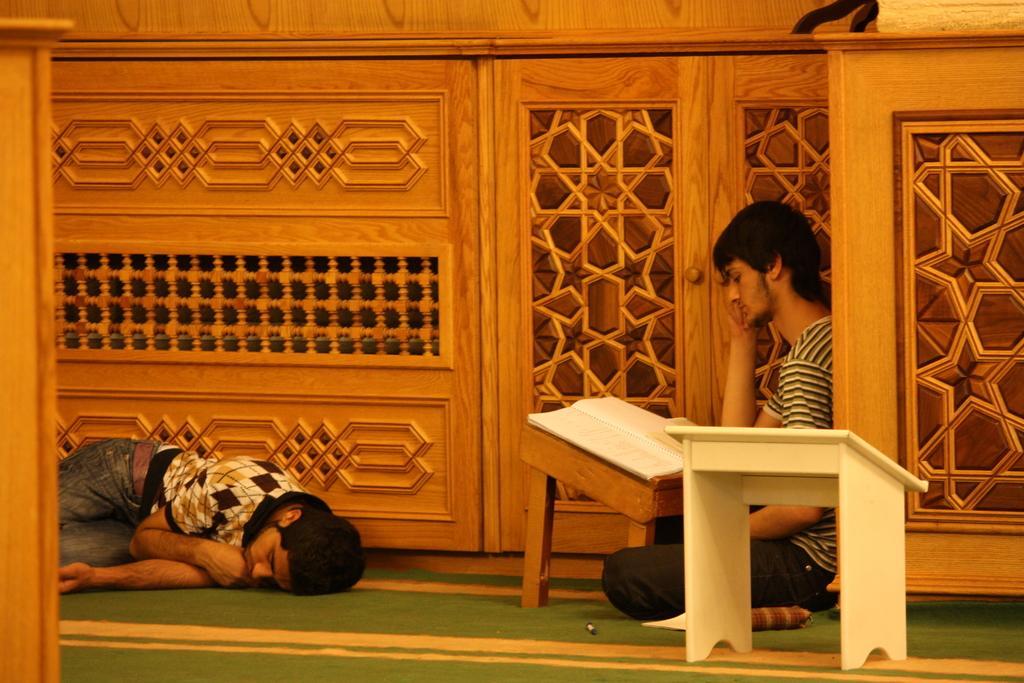How would you summarize this image in a sentence or two? On the right side, we see a wooden wall. In the right bottom, we see a white stool. Beside that, we see a man is sitting on the floor. In front of him, we see a stool on which a book is placed. I think he is reading the book. On the left side, we see a man is sleeping on the floor. At the bottom, we see a carpet in green color. In the background, we see a wooden wall. 